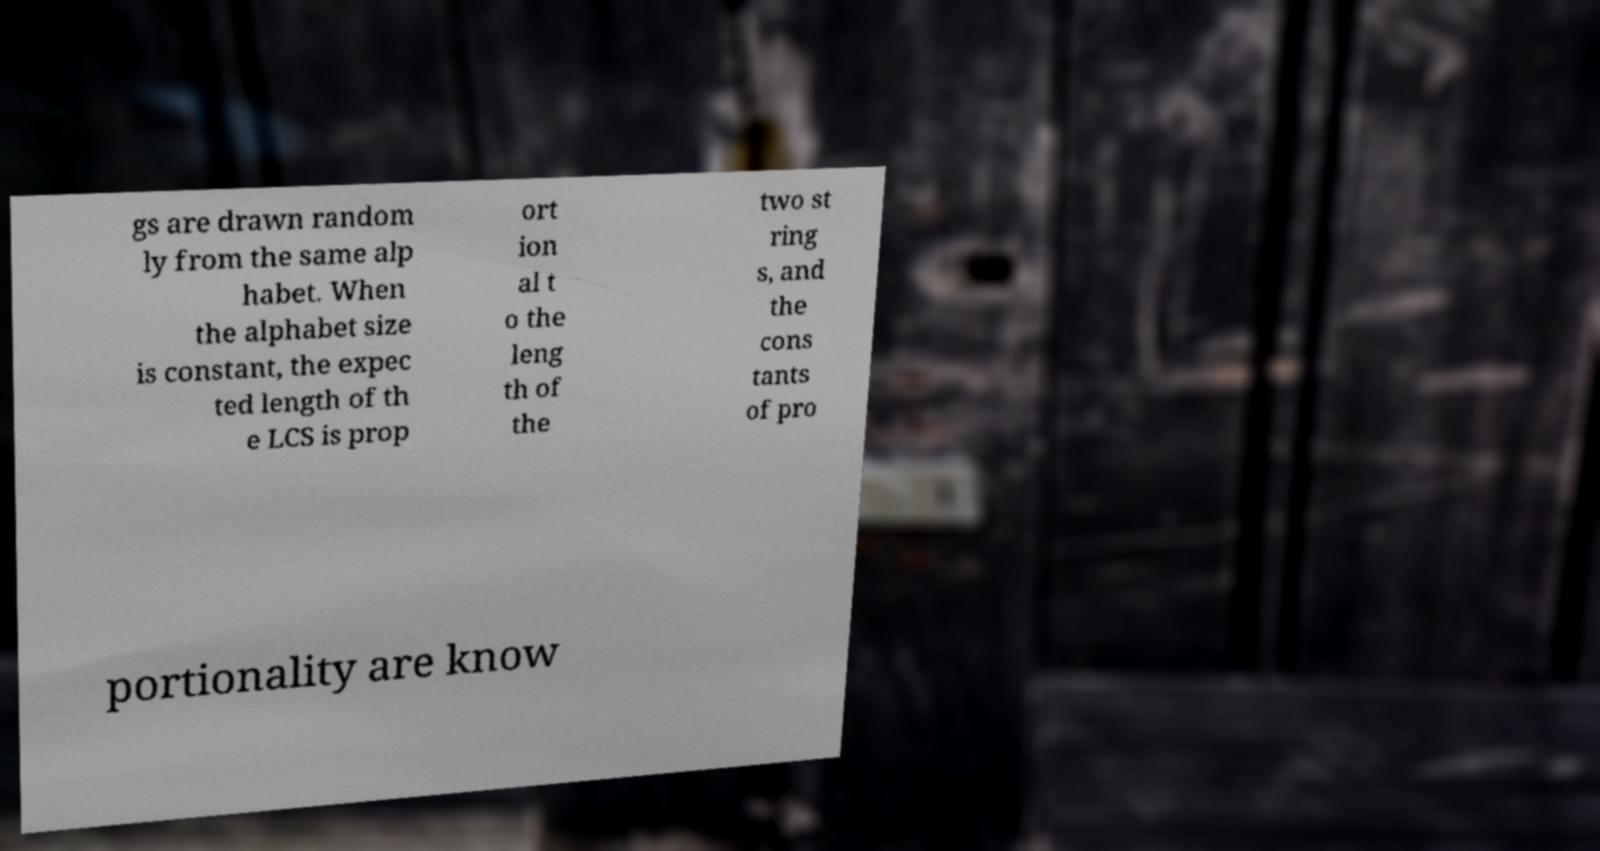Can you read and provide the text displayed in the image?This photo seems to have some interesting text. Can you extract and type it out for me? gs are drawn random ly from the same alp habet. When the alphabet size is constant, the expec ted length of th e LCS is prop ort ion al t o the leng th of the two st ring s, and the cons tants of pro portionality are know 